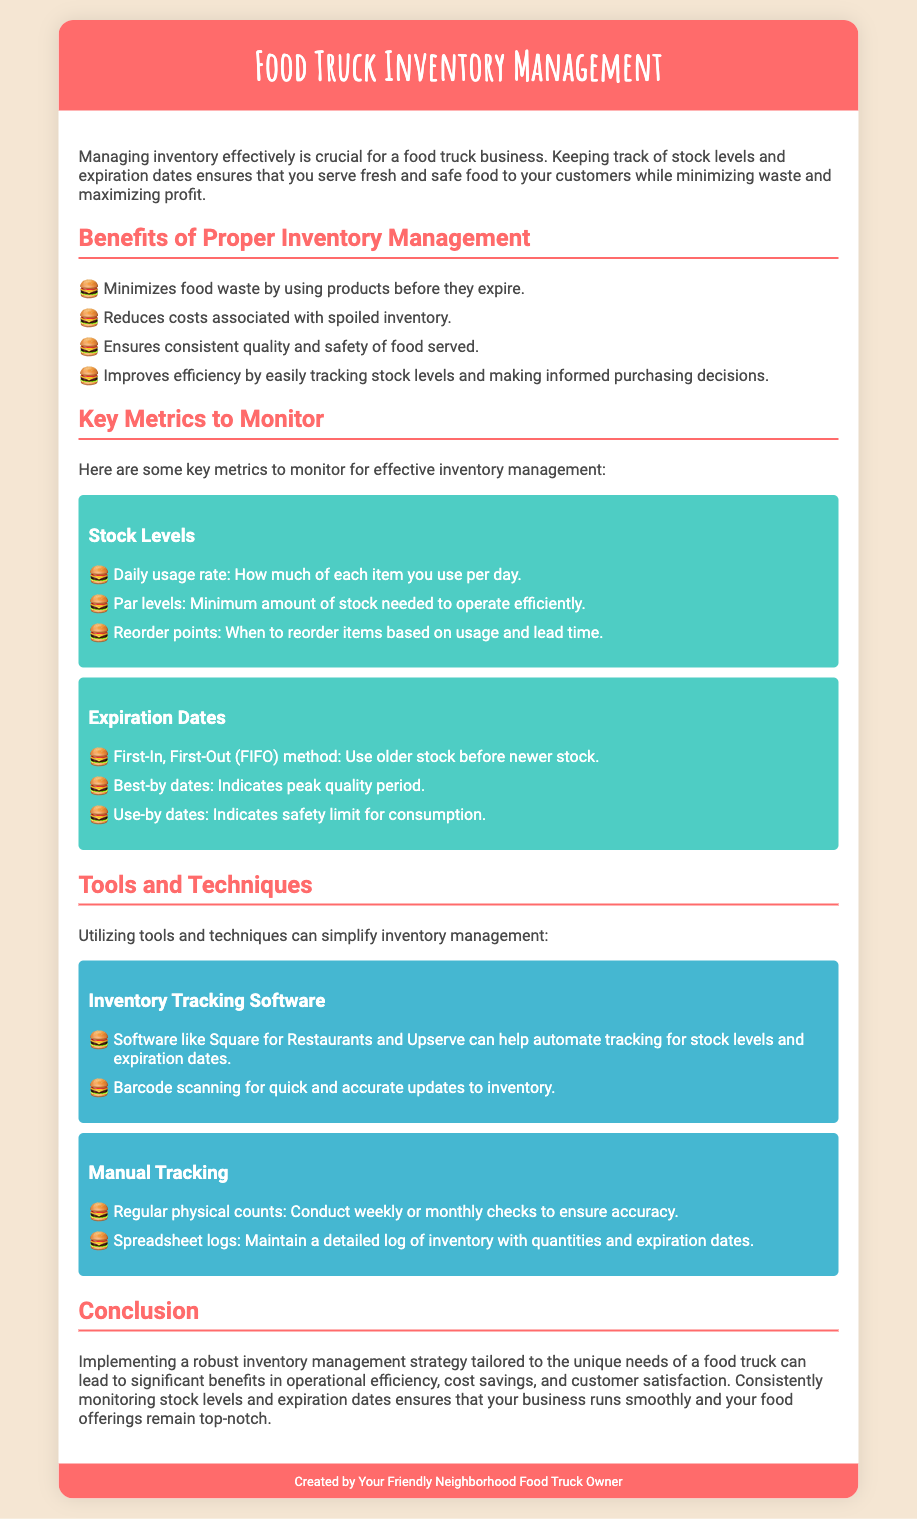What is the title of the document? The title of the document is found in the header section, indicating its main focus.
Answer: Food Truck Inventory Management What is the benefit of proper inventory management? The document lists benefits clearly, with one listed first.
Answer: Minimizes food waste by using products before they expire What does FIFO stand for? FIFO is mentioned in the section on expiration dates and is a common inventory management method.
Answer: First-In, First-Out What type of software is suggested for inventory tracking? The document mentions specific software tools for simplifying inventory management.
Answer: Square for Restaurants How often should regular physical counts be conducted? The document specifies a frequency for physical counts under the manual tracking section.
Answer: Weekly or monthly What is the color of the header? The document describes the color of the header in the style section, providing a specific detail about the design.
Answer: Red What are par levels? This term is defined in the metrics section, indicating a specific inventory measurement.
Answer: Minimum amount of stock needed to operate efficiently What method is used to manage expiration dates effectively? The document highlights a specific method to ensure proper usage of inventory relative to expiration.
Answer: FIFO method 